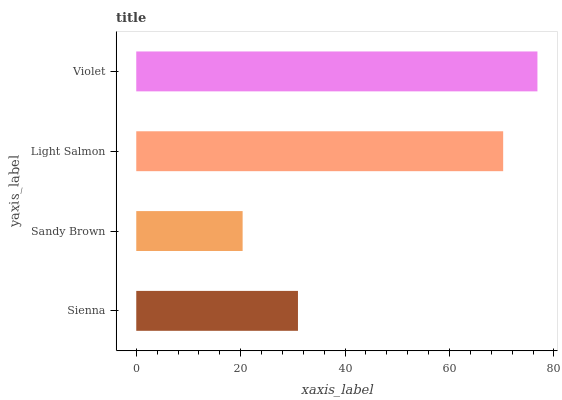Is Sandy Brown the minimum?
Answer yes or no. Yes. Is Violet the maximum?
Answer yes or no. Yes. Is Light Salmon the minimum?
Answer yes or no. No. Is Light Salmon the maximum?
Answer yes or no. No. Is Light Salmon greater than Sandy Brown?
Answer yes or no. Yes. Is Sandy Brown less than Light Salmon?
Answer yes or no. Yes. Is Sandy Brown greater than Light Salmon?
Answer yes or no. No. Is Light Salmon less than Sandy Brown?
Answer yes or no. No. Is Light Salmon the high median?
Answer yes or no. Yes. Is Sienna the low median?
Answer yes or no. Yes. Is Sienna the high median?
Answer yes or no. No. Is Violet the low median?
Answer yes or no. No. 